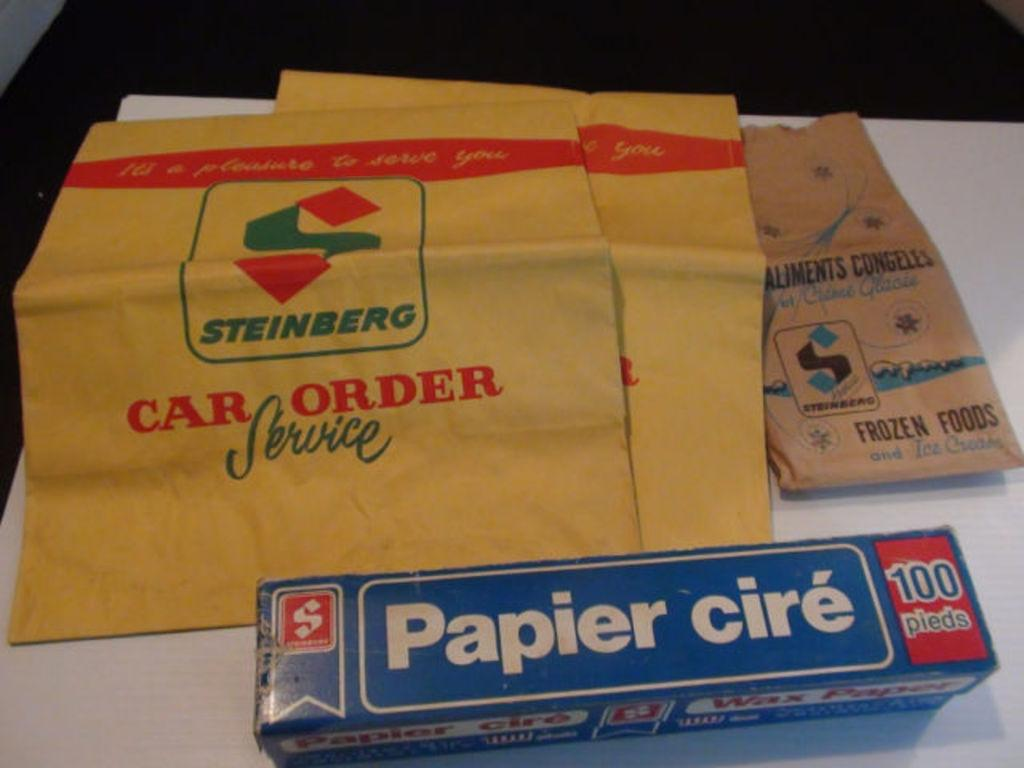<image>
Relay a brief, clear account of the picture shown. A blue box with Papier cire printed on it with envelopes next to it. 